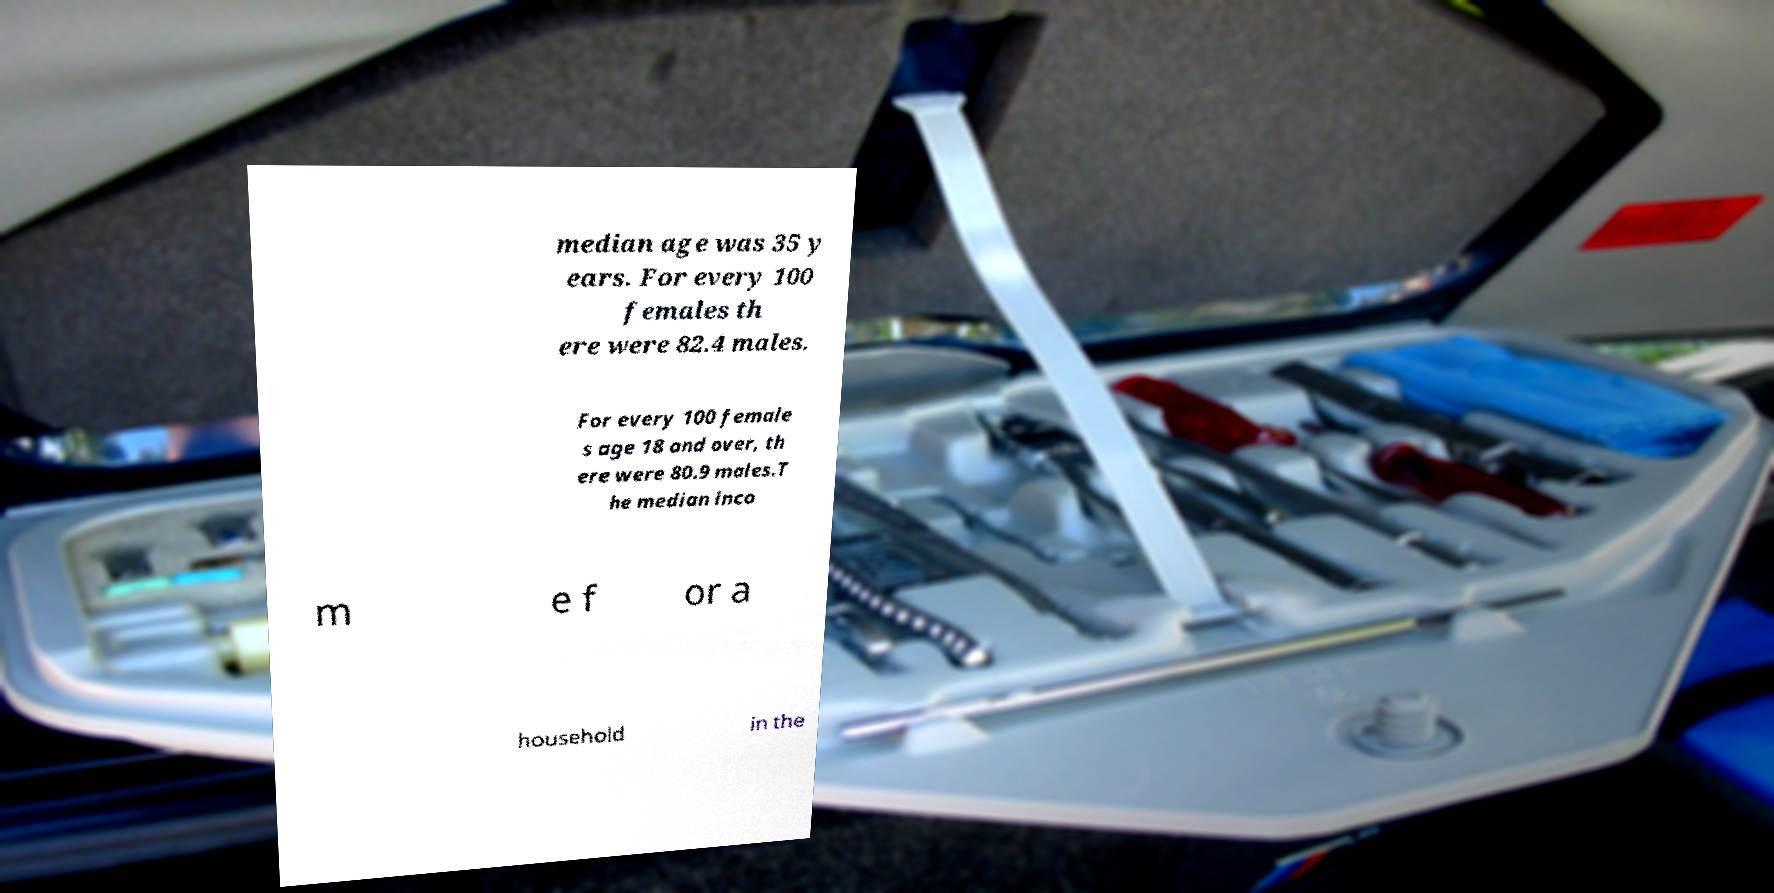Can you accurately transcribe the text from the provided image for me? median age was 35 y ears. For every 100 females th ere were 82.4 males. For every 100 female s age 18 and over, th ere were 80.9 males.T he median inco m e f or a household in the 